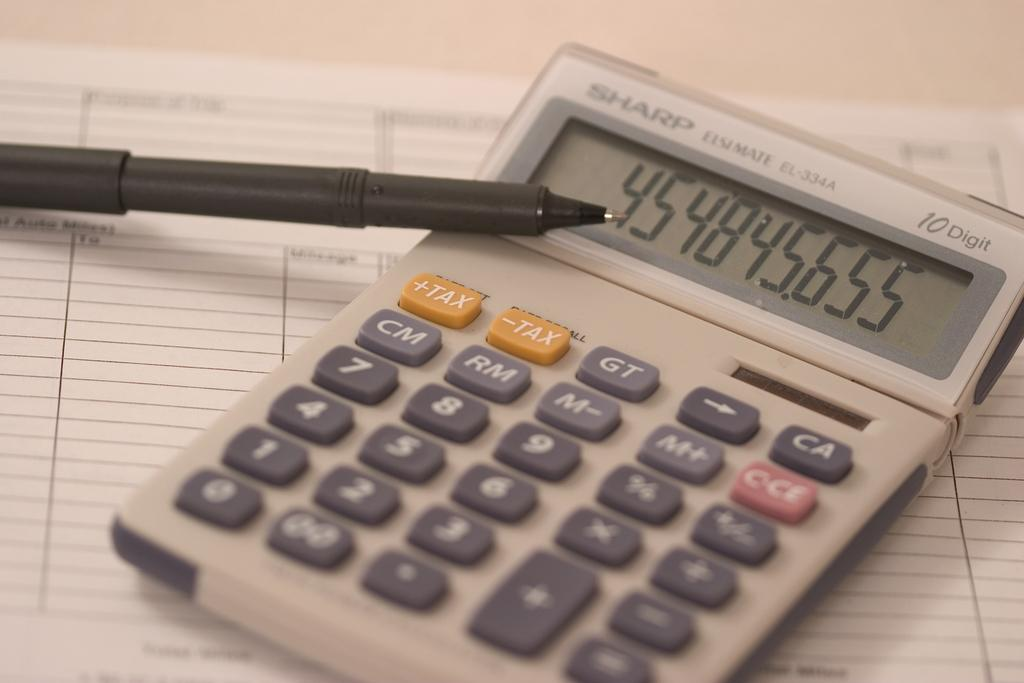<image>
Write a terse but informative summary of the picture. A sharp calculator sitting on a ledger type of page. 